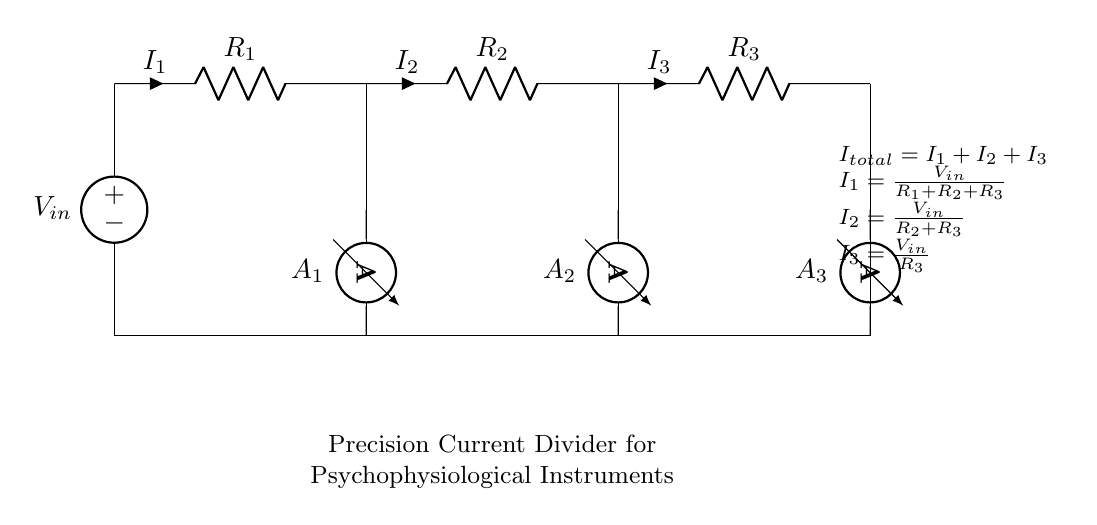What is the total current in this circuit? The total current is the sum of all individual currents in the circuit. According to the formula given in the diagram, \( I_{total} = I_1 + I_2 + I_3 \).
Answer: I total What component measures the current flowing through resistor R1? The component that measures the current through R1 is labeled A1, which is an ammeter directly connected to that branch of the circuit.
Answer: A1 What is the role of the voltage source in this circuit? The voltage source, labeled as \( V_{in} \), provides the necessary electrical potential to drive the current through the resistors and thus through the ammeter.
Answer: Supply voltage What is the formula for the current through R2? The current through R2, labeled \( I_2 \), can be calculated using the formula provided in the diagram: \( I_2 = \frac{V_{in}}{R_2 + R_3} \).
Answer: V in / (R2 + R3) How does the resistance affect the individual currents in this circuit? The individual currents are inversely proportional to the resistance values in parallel; higher resistance results in lower current based on Ohm's law, as seen in the formulas for \( I_1 \), \( I_2 \), and \( I_3 \).
Answer: Higher resistance = lower current What does \( R_1 \), \( R_2 \), and \( R_3 \) represent in terms of the function of this circuit? \( R_1 \), \( R_2 \), and \( R_3 \) represent the resistive elements in the precision current divider, defining how the input voltage divides into the corresponding currents across each resistor.
Answer: Resistors 